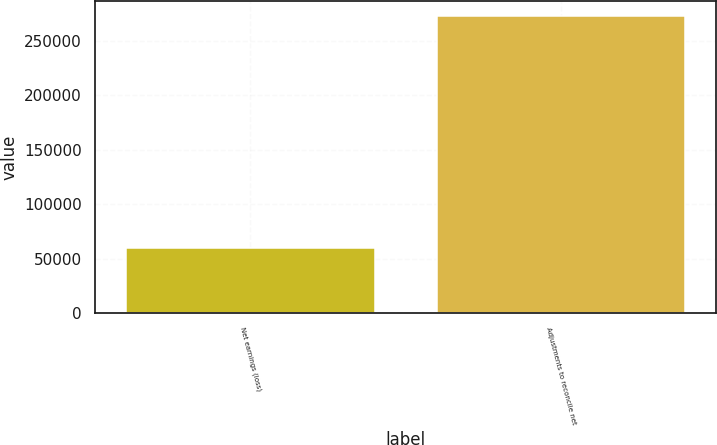<chart> <loc_0><loc_0><loc_500><loc_500><bar_chart><fcel>Net earnings (loss)<fcel>Adjustments to reconcile net<nl><fcel>60285<fcel>273227<nl></chart> 